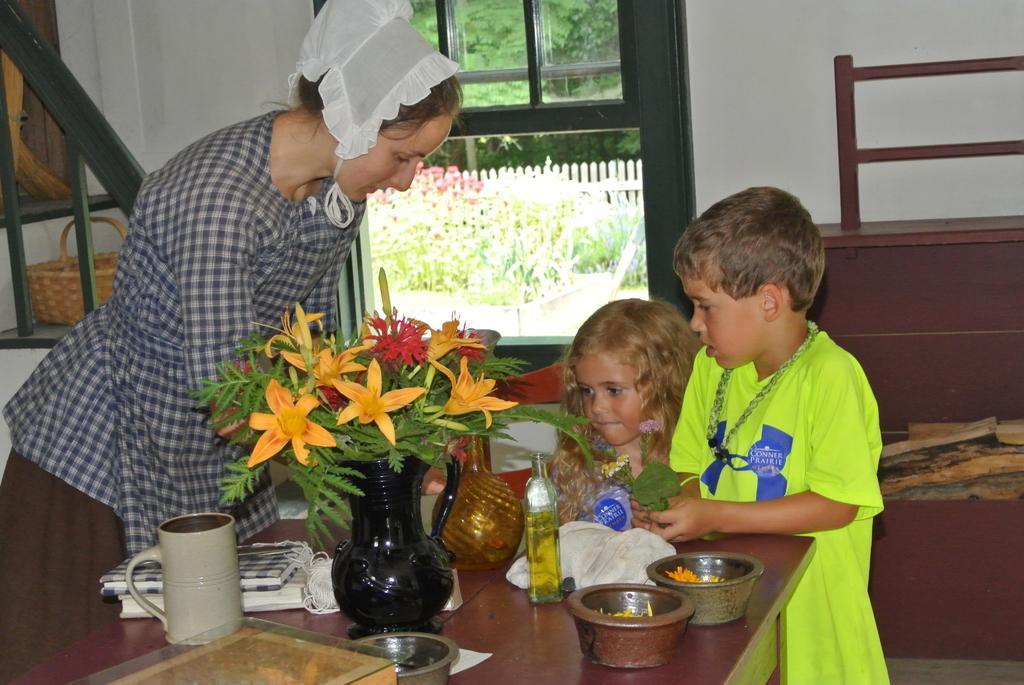Describe this image in one or two sentences. In this image we can see three persons, in front of them, we can see a table, on the table, we can see the bowls, flower vase and some other objects, also we can see a basket and a window, through the window we can see some plants. 